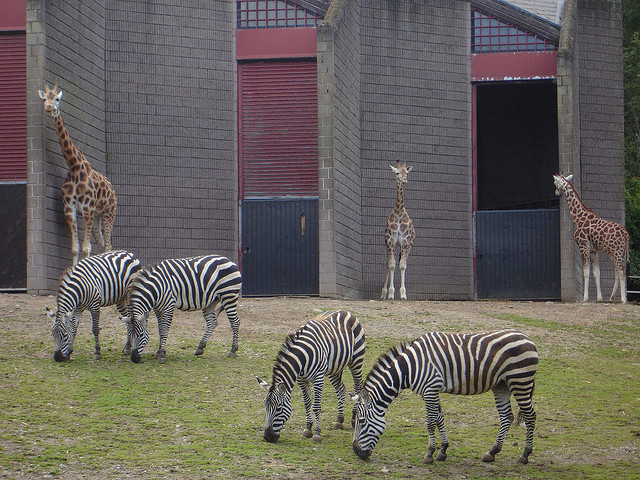<image>What kind of animals? It is ambiguous what kind of animals are in the image. It could be zebras, giraffes, or a horse.
 What kind of animals? I don't know what kind of animals are in the image. It can be zebras, giraffes, or both. 